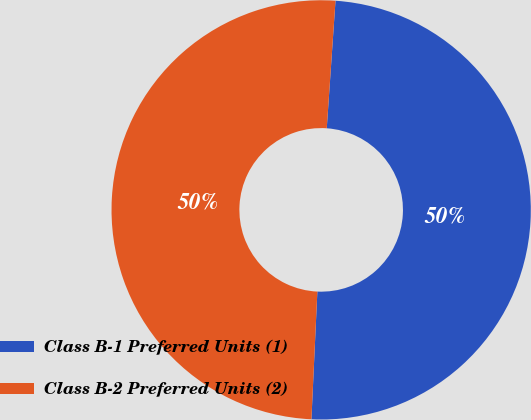<chart> <loc_0><loc_0><loc_500><loc_500><pie_chart><fcel>Class B-1 Preferred Units (1)<fcel>Class B-2 Preferred Units (2)<nl><fcel>49.65%<fcel>50.35%<nl></chart> 